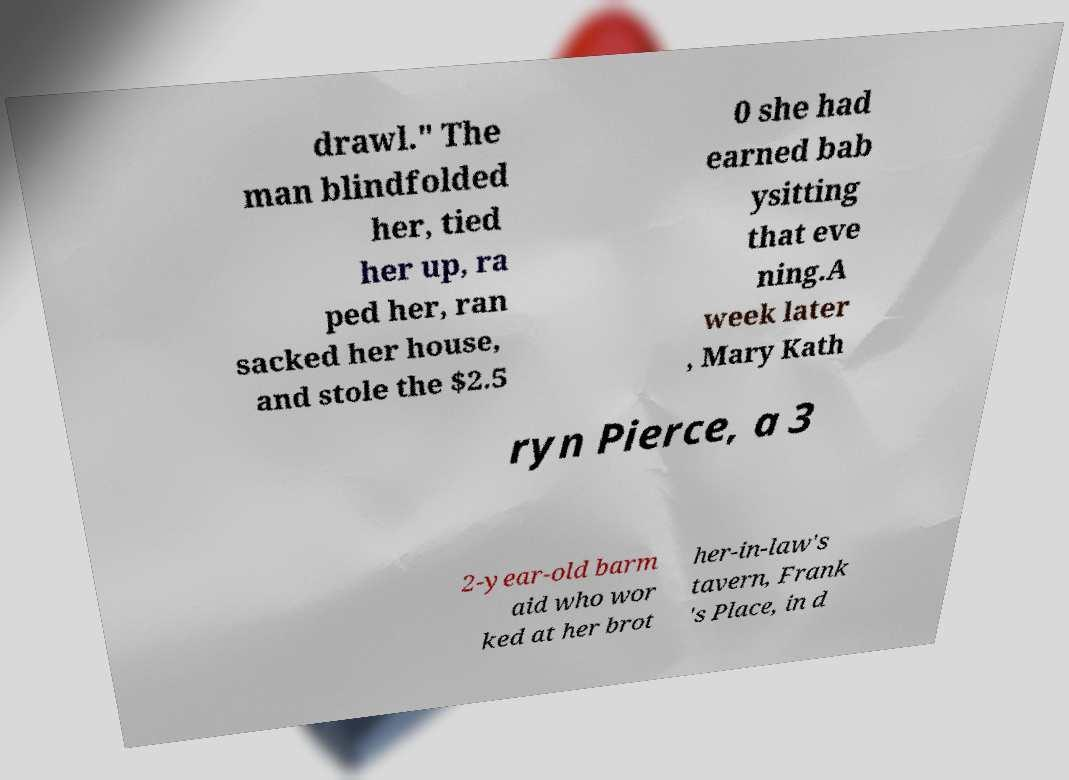Could you extract and type out the text from this image? drawl." The man blindfolded her, tied her up, ra ped her, ran sacked her house, and stole the $2.5 0 she had earned bab ysitting that eve ning.A week later , Mary Kath ryn Pierce, a 3 2-year-old barm aid who wor ked at her brot her-in-law's tavern, Frank 's Place, in d 